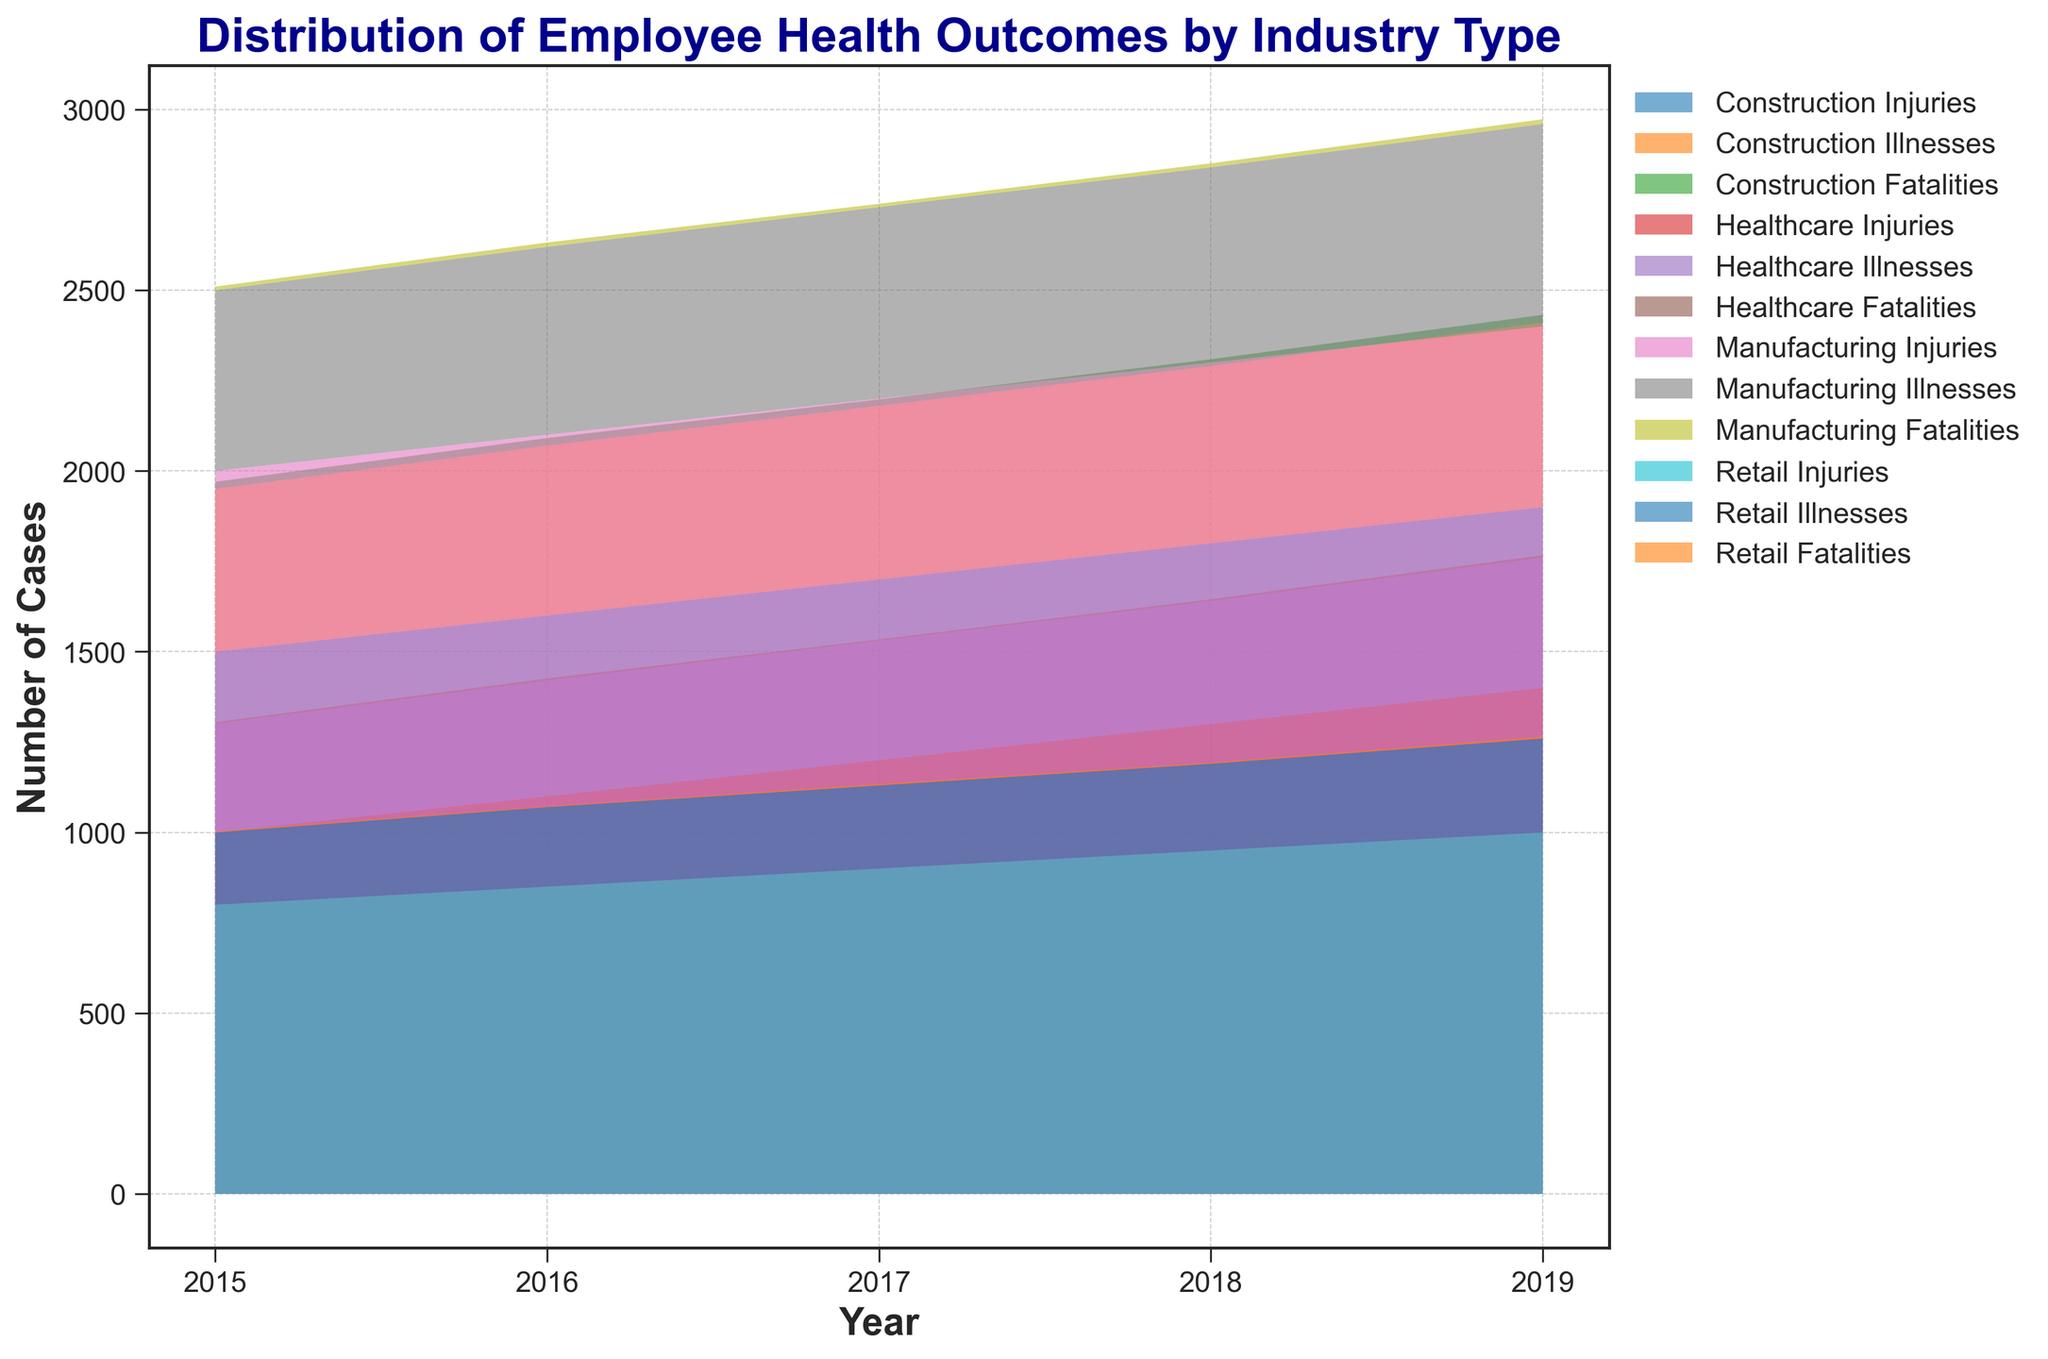What was the total number of injuries in the Healthcare industry from 2015 to 2019? To find this, sum the values for injuries in Healthcare from 2015 to 2019. From the chart, the numbers are 1000, 1100, 1200, 1300, and 1400. Adding these gives: 1000 + 1100 + 1200 + 1300 + 1400 = 6000.
Answer: 6000 Which industry had the highest number of fatalities in any single year? To determine this, look for the highest peak in the fatalities area of the chart and identify the corresponding industry. The highest occurs in Construction in 2019 with 22 fatalities.
Answer: Construction How does the trend in illnesses compare between the Manufacturing and Construction industries over the years? For comparison, observe the trend lines of illnesses for both industries. Both Manufacturing and Construction show a general upward trend over the years, but Construction starts lower and ends higher than Manufacturing.
Answer: Both increase, but Construction rises more In which year did the Manufacturing industry have the lowest number of fatalities? To find this, examine the lowest point in the Manufacturing fatalities area across the years. The lowest point is in 2017 with 9 fatalities.
Answer: 2017 What is the average number of fatalities per year in the Retail industry from 2015 to 2019? Compute the mean by summing fatalities in Retail for each year from 2015 to 2019 and then dividing by the number of years. The values are 3, 2, 4, 3, and 5: (3 + 2 + 4 + 3 + 5) / 5 = 3.4.
Answer: 3.4 Between Manufacturing and Healthcare, which industry had a greater increase in injuries from 2015 to 2019, and by how much? First, calculate the increase for each industry: Manufacturing’s increase is 2400 - 2000 = 400; Healthcare’s increase is 1400 - 1000 = 400. Both industries had an equal increase of 400.
Answer: Equal, both increased by 400 What is the combined number of illnesses across all industries in 2017? Sum the 2017 values for illnesses in all industries: Manufacturing (530), Construction (480), Healthcare (330), and Retail (230). Hence, 530 + 480 + 330 + 230 = 1570.
Answer: 1570 Which industry showed the most consistent number of injuries over the years? The industry with the least variation in the number of injuries will have a flatter area. Healthcare shows the most consistent pattern with a steady increase.
Answer: Healthcare What was the total number of cases (injuries + illnesses + fatalities) for Construction in 2018? Add the 2018 values for injuries, illnesses, and fatalities for Construction: 1800 (injuries) + 490 (illnesses) + 19 (fatalities). The sum is 1800 + 490 + 19 = 2309.
Answer: 2309 Did the total number of retail illnesses exceed 1000 from 2015 to 2019? Sum the Retail illnesses over these years: 200, 220, 230, 240, and 260. The total is 200 + 220 + 230 + 240 + 260 = 1150, which exceeds 1000.
Answer: Yes, 1150 